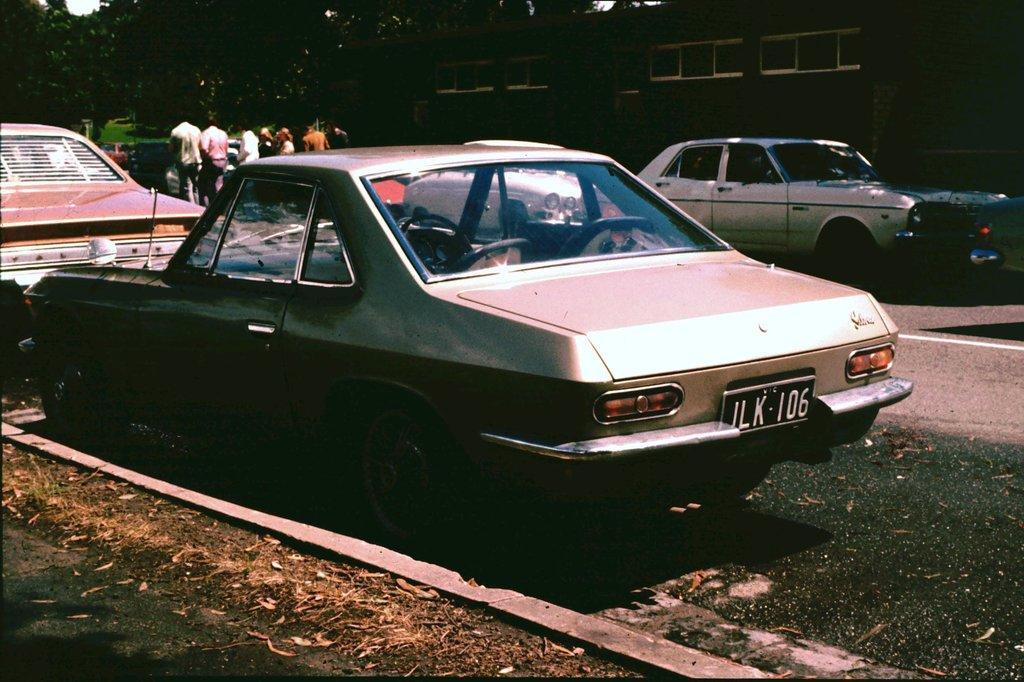In one or two sentences, can you explain what this image depicts? In this image, there are few cars, which are parked. I can see a group of people. In the background, there are trees and a building. At the bottom left corner of the image, I can see a pathway. 